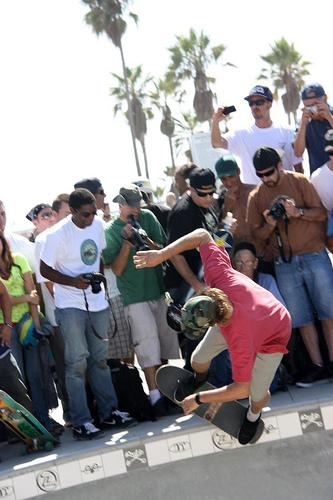What are people filming and taking pictures of?

Choices:
A) accident
B) tricks
C) skateboards
D) model tricks 